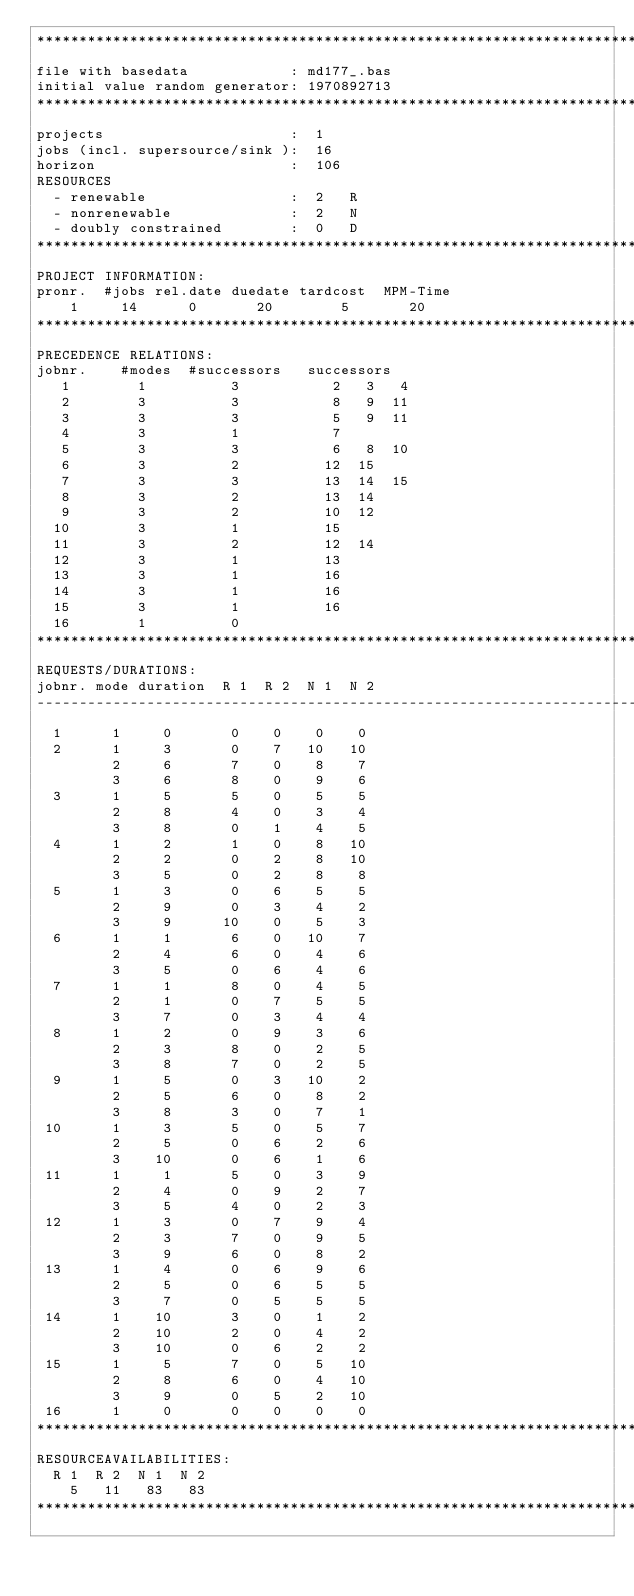Convert code to text. <code><loc_0><loc_0><loc_500><loc_500><_ObjectiveC_>************************************************************************
file with basedata            : md177_.bas
initial value random generator: 1970892713
************************************************************************
projects                      :  1
jobs (incl. supersource/sink ):  16
horizon                       :  106
RESOURCES
  - renewable                 :  2   R
  - nonrenewable              :  2   N
  - doubly constrained        :  0   D
************************************************************************
PROJECT INFORMATION:
pronr.  #jobs rel.date duedate tardcost  MPM-Time
    1     14      0       20        5       20
************************************************************************
PRECEDENCE RELATIONS:
jobnr.    #modes  #successors   successors
   1        1          3           2   3   4
   2        3          3           8   9  11
   3        3          3           5   9  11
   4        3          1           7
   5        3          3           6   8  10
   6        3          2          12  15
   7        3          3          13  14  15
   8        3          2          13  14
   9        3          2          10  12
  10        3          1          15
  11        3          2          12  14
  12        3          1          13
  13        3          1          16
  14        3          1          16
  15        3          1          16
  16        1          0        
************************************************************************
REQUESTS/DURATIONS:
jobnr. mode duration  R 1  R 2  N 1  N 2
------------------------------------------------------------------------
  1      1     0       0    0    0    0
  2      1     3       0    7   10   10
         2     6       7    0    8    7
         3     6       8    0    9    6
  3      1     5       5    0    5    5
         2     8       4    0    3    4
         3     8       0    1    4    5
  4      1     2       1    0    8   10
         2     2       0    2    8   10
         3     5       0    2    8    8
  5      1     3       0    6    5    5
         2     9       0    3    4    2
         3     9      10    0    5    3
  6      1     1       6    0   10    7
         2     4       6    0    4    6
         3     5       0    6    4    6
  7      1     1       8    0    4    5
         2     1       0    7    5    5
         3     7       0    3    4    4
  8      1     2       0    9    3    6
         2     3       8    0    2    5
         3     8       7    0    2    5
  9      1     5       0    3   10    2
         2     5       6    0    8    2
         3     8       3    0    7    1
 10      1     3       5    0    5    7
         2     5       0    6    2    6
         3    10       0    6    1    6
 11      1     1       5    0    3    9
         2     4       0    9    2    7
         3     5       4    0    2    3
 12      1     3       0    7    9    4
         2     3       7    0    9    5
         3     9       6    0    8    2
 13      1     4       0    6    9    6
         2     5       0    6    5    5
         3     7       0    5    5    5
 14      1    10       3    0    1    2
         2    10       2    0    4    2
         3    10       0    6    2    2
 15      1     5       7    0    5   10
         2     8       6    0    4   10
         3     9       0    5    2   10
 16      1     0       0    0    0    0
************************************************************************
RESOURCEAVAILABILITIES:
  R 1  R 2  N 1  N 2
    5   11   83   83
************************************************************************
</code> 